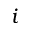Convert formula to latex. <formula><loc_0><loc_0><loc_500><loc_500>i</formula> 